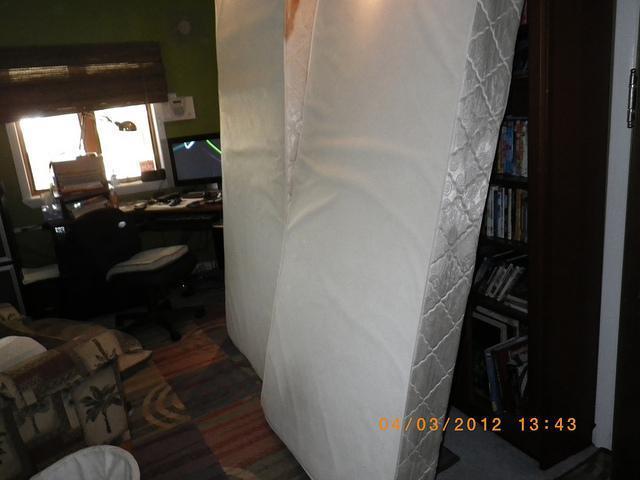How many mattresses are there?
Give a very brief answer. 2. How many beds are in the photo?
Give a very brief answer. 2. How many books can you see?
Give a very brief answer. 2. 